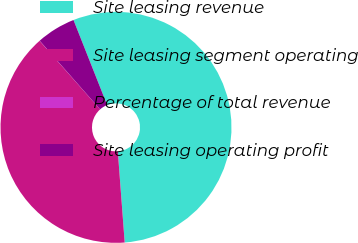<chart> <loc_0><loc_0><loc_500><loc_500><pie_chart><fcel>Site leasing revenue<fcel>Site leasing segment operating<fcel>Percentage of total revenue<fcel>Site leasing operating profit<nl><fcel>54.8%<fcel>39.69%<fcel>0.02%<fcel>5.49%<nl></chart> 